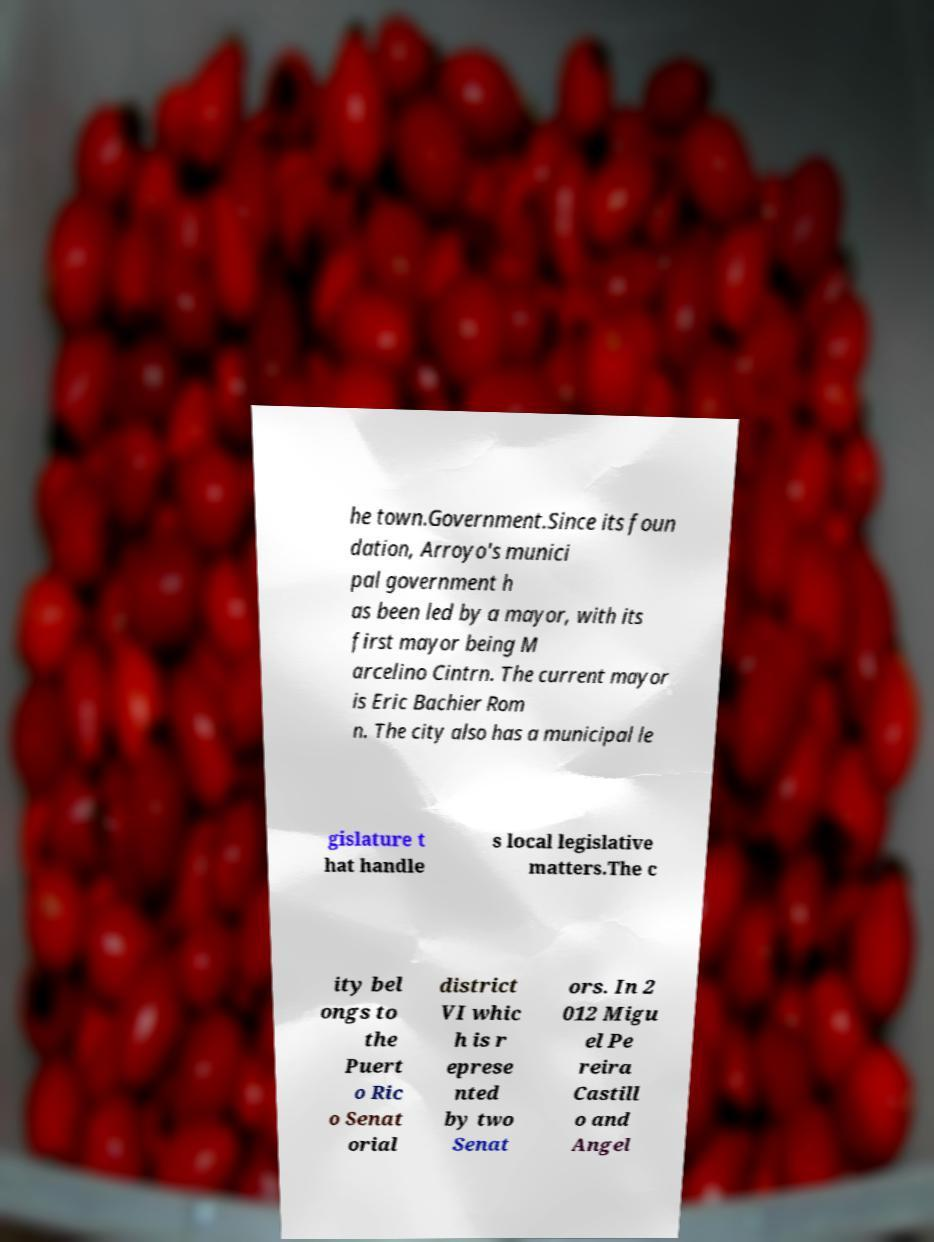Can you accurately transcribe the text from the provided image for me? he town.Government.Since its foun dation, Arroyo's munici pal government h as been led by a mayor, with its first mayor being M arcelino Cintrn. The current mayor is Eric Bachier Rom n. The city also has a municipal le gislature t hat handle s local legislative matters.The c ity bel ongs to the Puert o Ric o Senat orial district VI whic h is r eprese nted by two Senat ors. In 2 012 Migu el Pe reira Castill o and Angel 